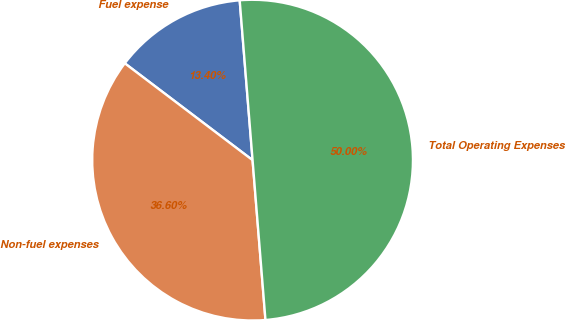Convert chart to OTSL. <chart><loc_0><loc_0><loc_500><loc_500><pie_chart><fcel>Fuel expense<fcel>Non-fuel expenses<fcel>Total Operating Expenses<nl><fcel>13.4%<fcel>36.6%<fcel>50.0%<nl></chart> 